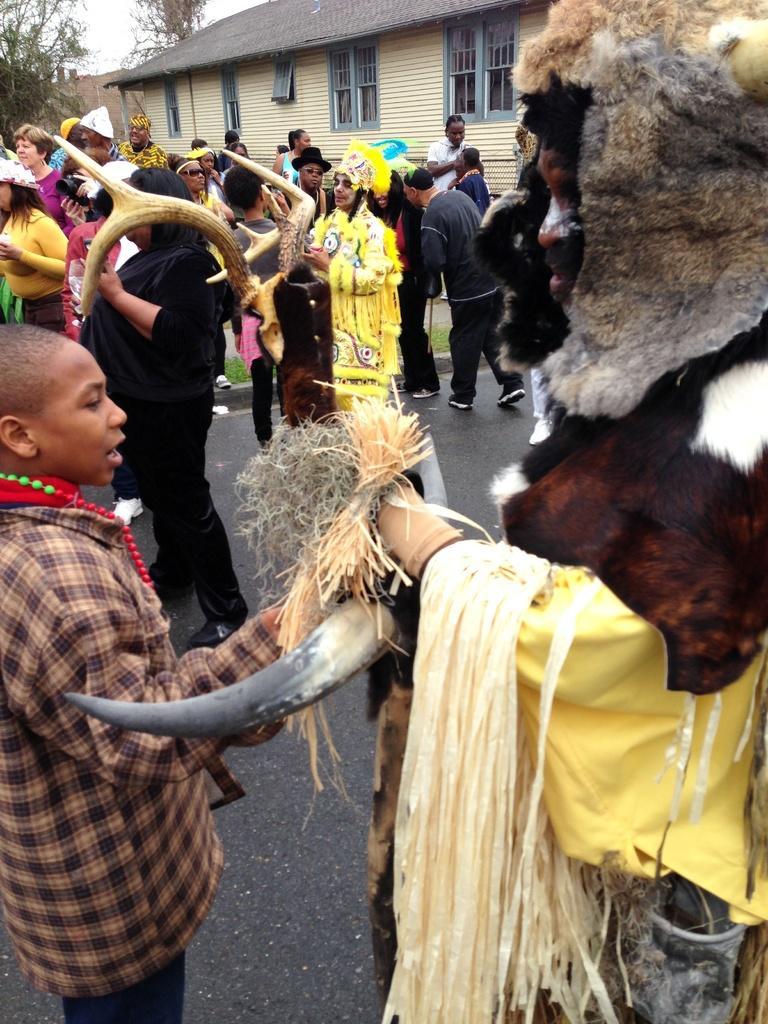Can you describe this image briefly? In the image on the road there are many people. Few are wearing mask and holding horns. In the background there is a building and trees. 